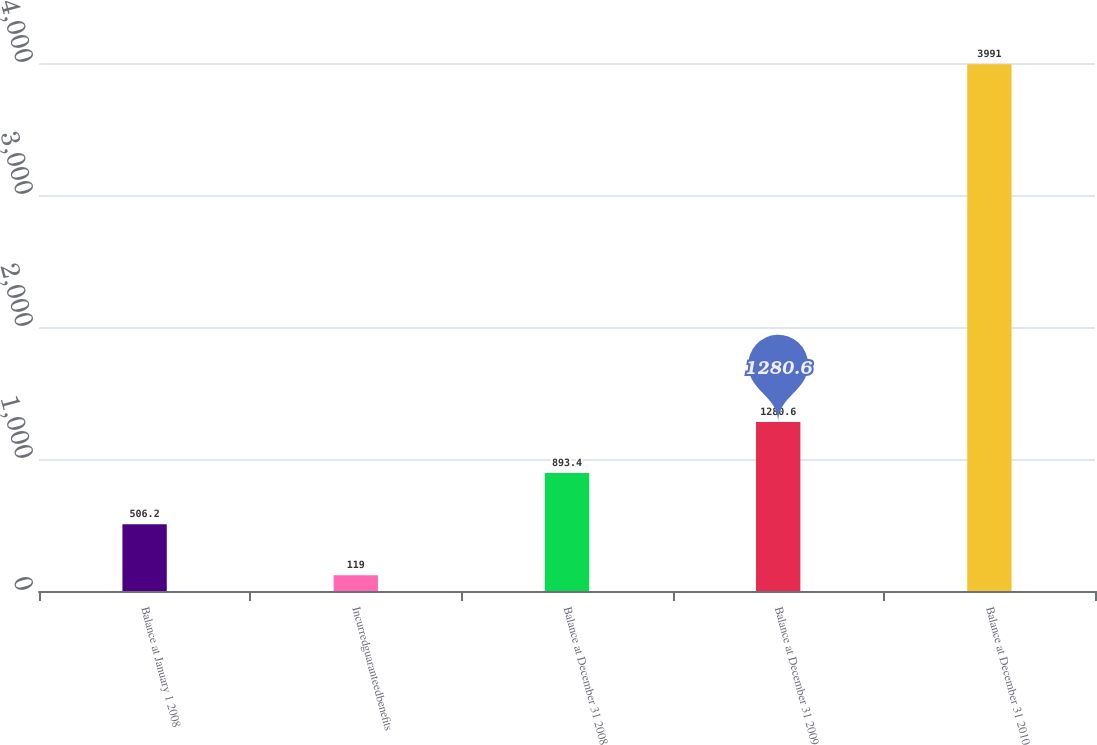Convert chart. <chart><loc_0><loc_0><loc_500><loc_500><bar_chart><fcel>Balance at January 1 2008<fcel>Incurredguaranteedbenefits<fcel>Balance at December 31 2008<fcel>Balance at December 31 2009<fcel>Balance at December 31 2010<nl><fcel>506.2<fcel>119<fcel>893.4<fcel>1280.6<fcel>3991<nl></chart> 